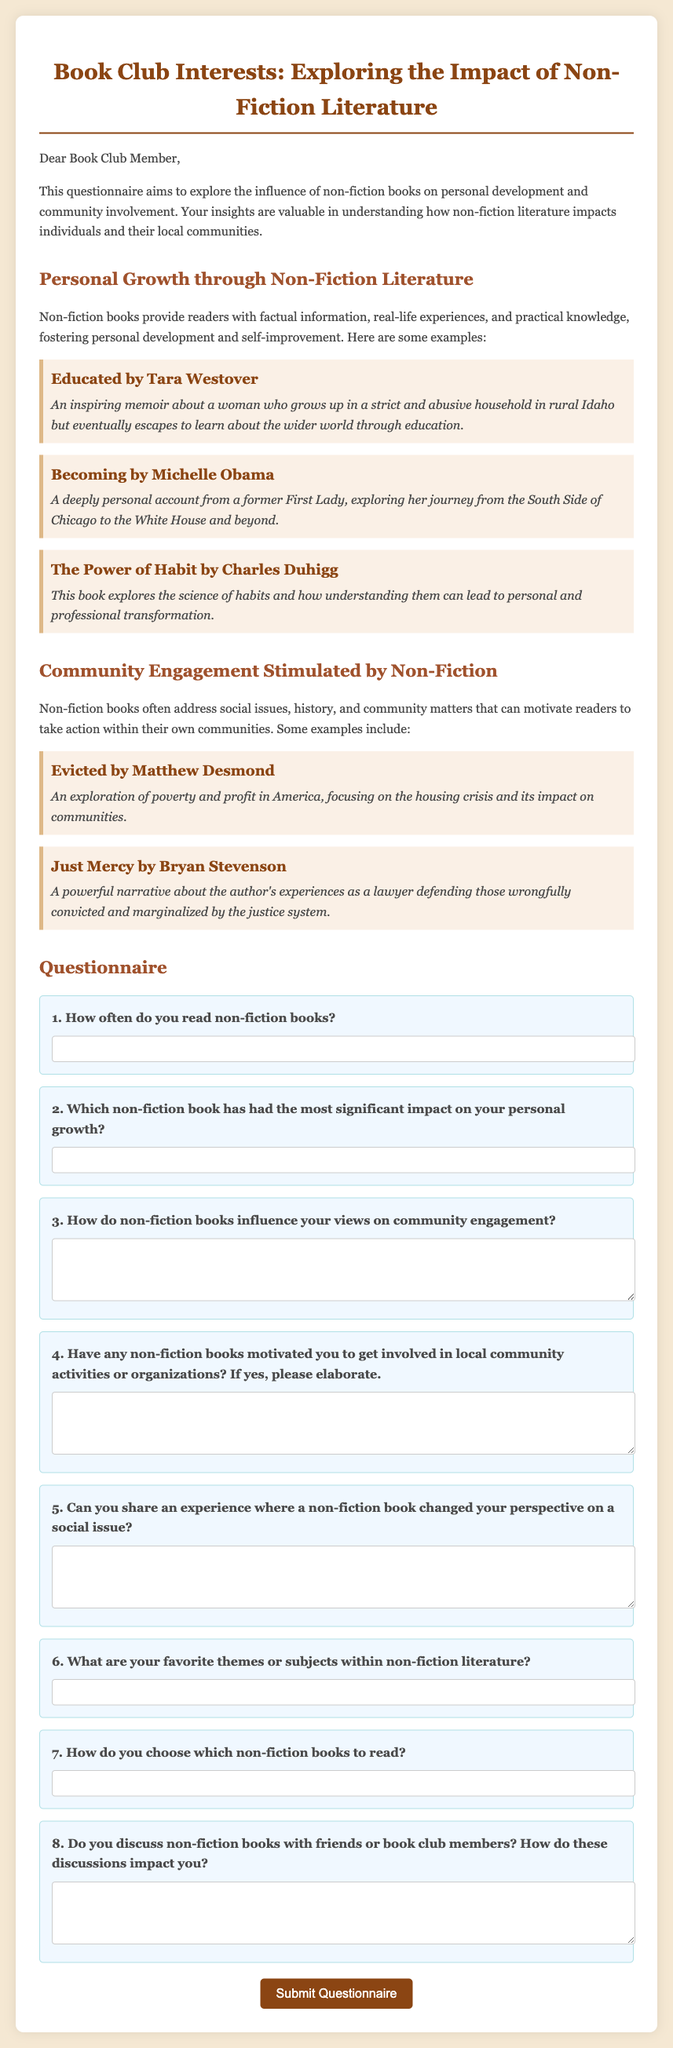What is the title of the questionnaire? The title of the questionnaire is mentioned at the top of the document.
Answer: Book Club Interests: Exploring the Impact of Non-Fiction Literature Who is the author of "Educated"? The author's name is listed alongside the book title in the document.
Answer: Tara Westover What are the two main themes of the questionnaire? The themes are specified in the respective sections of the document.
Answer: Personal Growth and Community Engagement How many non-fiction books are mentioned in the document? The document contains a list of non-fiction books under two sections, which can be counted.
Answer: 5 What type of response does question 4 ask for? The type of response is indicated by the format of the question and its structure.
Answer: Elaborate response What is the format of the input for question 1? The document specifies what kind of input is required for each question.
Answer: Text input What is the primary purpose of the questionnaire? The purpose is stated in the introductory paragraph of the document.
Answer: Explore the influence of non-fiction books on personal development and community involvement What color is the background of the container? The specific color is described within the style section of the document.
Answer: White 